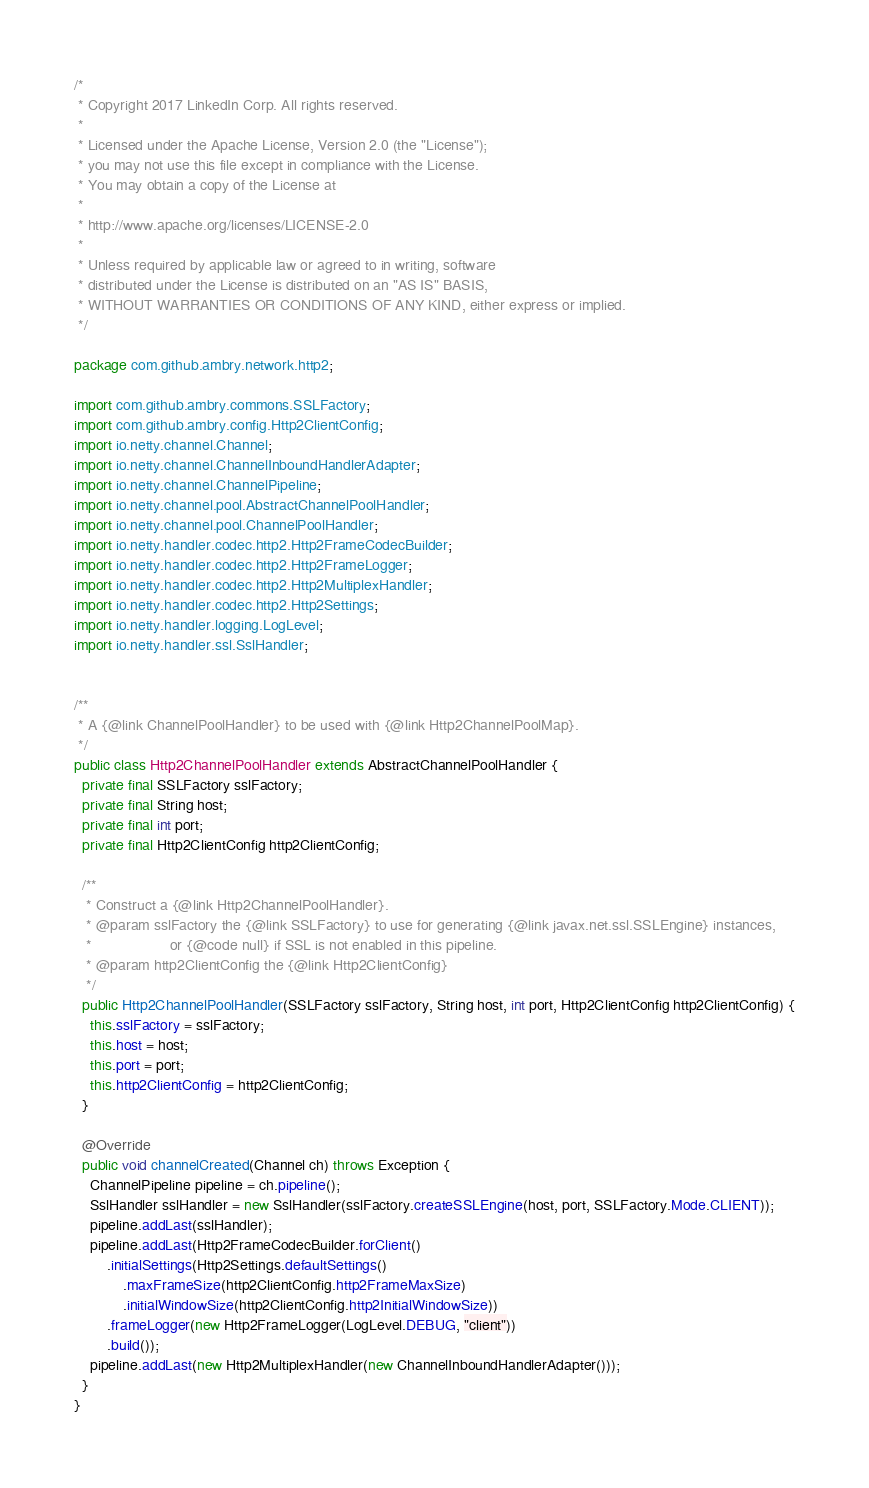Convert code to text. <code><loc_0><loc_0><loc_500><loc_500><_Java_>/*
 * Copyright 2017 LinkedIn Corp. All rights reserved.
 *
 * Licensed under the Apache License, Version 2.0 (the "License");
 * you may not use this file except in compliance with the License.
 * You may obtain a copy of the License at
 *
 * http://www.apache.org/licenses/LICENSE-2.0
 *
 * Unless required by applicable law or agreed to in writing, software
 * distributed under the License is distributed on an "AS IS" BASIS,
 * WITHOUT WARRANTIES OR CONDITIONS OF ANY KIND, either express or implied.
 */

package com.github.ambry.network.http2;

import com.github.ambry.commons.SSLFactory;
import com.github.ambry.config.Http2ClientConfig;
import io.netty.channel.Channel;
import io.netty.channel.ChannelInboundHandlerAdapter;
import io.netty.channel.ChannelPipeline;
import io.netty.channel.pool.AbstractChannelPoolHandler;
import io.netty.channel.pool.ChannelPoolHandler;
import io.netty.handler.codec.http2.Http2FrameCodecBuilder;
import io.netty.handler.codec.http2.Http2FrameLogger;
import io.netty.handler.codec.http2.Http2MultiplexHandler;
import io.netty.handler.codec.http2.Http2Settings;
import io.netty.handler.logging.LogLevel;
import io.netty.handler.ssl.SslHandler;


/**
 * A {@link ChannelPoolHandler} to be used with {@link Http2ChannelPoolMap}.
 */
public class Http2ChannelPoolHandler extends AbstractChannelPoolHandler {
  private final SSLFactory sslFactory;
  private final String host;
  private final int port;
  private final Http2ClientConfig http2ClientConfig;

  /**
   * Construct a {@link Http2ChannelPoolHandler}.
   * @param sslFactory the {@link SSLFactory} to use for generating {@link javax.net.ssl.SSLEngine} instances,
   *                   or {@code null} if SSL is not enabled in this pipeline.
   * @param http2ClientConfig the {@link Http2ClientConfig}
   */
  public Http2ChannelPoolHandler(SSLFactory sslFactory, String host, int port, Http2ClientConfig http2ClientConfig) {
    this.sslFactory = sslFactory;
    this.host = host;
    this.port = port;
    this.http2ClientConfig = http2ClientConfig;
  }

  @Override
  public void channelCreated(Channel ch) throws Exception {
    ChannelPipeline pipeline = ch.pipeline();
    SslHandler sslHandler = new SslHandler(sslFactory.createSSLEngine(host, port, SSLFactory.Mode.CLIENT));
    pipeline.addLast(sslHandler);
    pipeline.addLast(Http2FrameCodecBuilder.forClient()
        .initialSettings(Http2Settings.defaultSettings()
            .maxFrameSize(http2ClientConfig.http2FrameMaxSize)
            .initialWindowSize(http2ClientConfig.http2InitialWindowSize))
        .frameLogger(new Http2FrameLogger(LogLevel.DEBUG, "client"))
        .build());
    pipeline.addLast(new Http2MultiplexHandler(new ChannelInboundHandlerAdapter()));
  }
}

</code> 